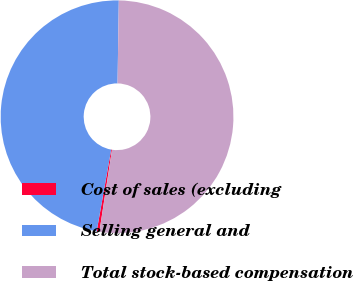Convert chart to OTSL. <chart><loc_0><loc_0><loc_500><loc_500><pie_chart><fcel>Cost of sales (excluding<fcel>Selling general and<fcel>Total stock-based compensation<nl><fcel>0.38%<fcel>47.44%<fcel>52.18%<nl></chart> 